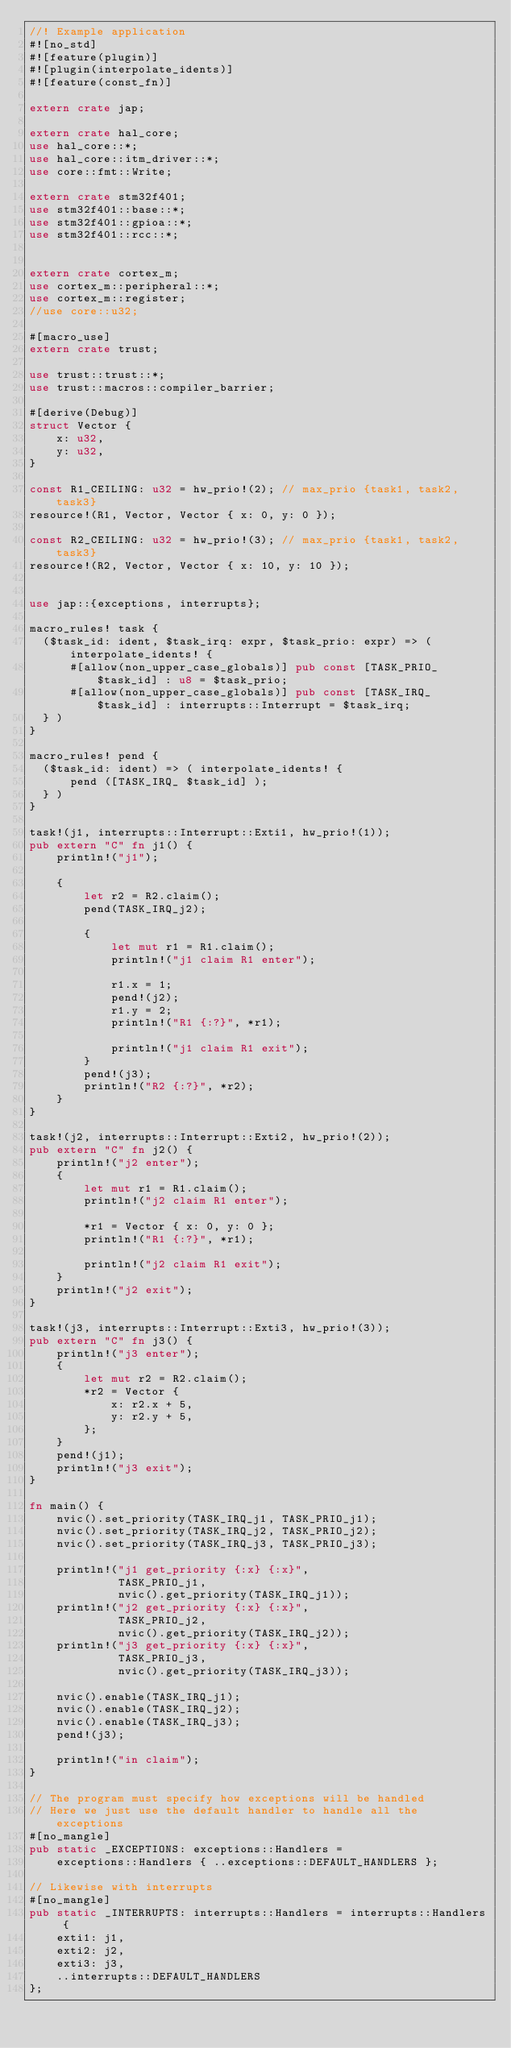Convert code to text. <code><loc_0><loc_0><loc_500><loc_500><_Rust_>//! Example application
#![no_std]
#![feature(plugin)]
#![plugin(interpolate_idents)]
#![feature(const_fn)]

extern crate jap;

extern crate hal_core;
use hal_core::*;
use hal_core::itm_driver::*;
use core::fmt::Write;

extern crate stm32f401;
use stm32f401::base::*;
use stm32f401::gpioa::*;
use stm32f401::rcc::*;


extern crate cortex_m;
use cortex_m::peripheral::*;
use cortex_m::register;
//use core::u32;

#[macro_use]
extern crate trust;

use trust::trust::*;
use trust::macros::compiler_barrier;

#[derive(Debug)]
struct Vector {
    x: u32,
    y: u32,
}

const R1_CEILING: u32 = hw_prio!(2); // max_prio {task1, task2, task3}
resource!(R1, Vector, Vector { x: 0, y: 0 });

const R2_CEILING: u32 = hw_prio!(3); // max_prio {task1, task2, task3}
resource!(R2, Vector, Vector { x: 10, y: 10 });


use jap::{exceptions, interrupts};

macro_rules! task {
  ($task_id: ident, $task_irq: expr, $task_prio: expr) => ( interpolate_idents! {
      #[allow(non_upper_case_globals)] pub const [TASK_PRIO_ $task_id] : u8 = $task_prio;
      #[allow(non_upper_case_globals)] pub const [TASK_IRQ_ $task_id] : interrupts::Interrupt = $task_irq; 
  } )
}

macro_rules! pend {
  ($task_id: ident) => ( interpolate_idents! {
      pend ([TASK_IRQ_ $task_id] ); 
  } )
}

task!(j1, interrupts::Interrupt::Exti1, hw_prio!(1));
pub extern "C" fn j1() {
    println!("j1");

    {
        let r2 = R2.claim();
        pend(TASK_IRQ_j2);

        {
            let mut r1 = R1.claim();
            println!("j1 claim R1 enter");

            r1.x = 1;
            pend!(j2);
            r1.y = 2;
            println!("R1 {:?}", *r1);

            println!("j1 claim R1 exit");
        }
        pend!(j3);
        println!("R2 {:?}", *r2);
    }
}

task!(j2, interrupts::Interrupt::Exti2, hw_prio!(2));
pub extern "C" fn j2() {
    println!("j2 enter");
    {
        let mut r1 = R1.claim();
        println!("j2 claim R1 enter");

        *r1 = Vector { x: 0, y: 0 };
        println!("R1 {:?}", *r1);

        println!("j2 claim R1 exit");
    }
    println!("j2 exit");
}

task!(j3, interrupts::Interrupt::Exti3, hw_prio!(3));
pub extern "C" fn j3() {
    println!("j3 enter");
    {
        let mut r2 = R2.claim();
        *r2 = Vector {
            x: r2.x + 5,
            y: r2.y + 5,
        };
    }
    pend!(j1);
    println!("j3 exit");
}

fn main() {
    nvic().set_priority(TASK_IRQ_j1, TASK_PRIO_j1);
    nvic().set_priority(TASK_IRQ_j2, TASK_PRIO_j2);
    nvic().set_priority(TASK_IRQ_j3, TASK_PRIO_j3);

    println!("j1 get_priority {:x} {:x}",
             TASK_PRIO_j1,
             nvic().get_priority(TASK_IRQ_j1));
    println!("j2 get_priority {:x} {:x}",
             TASK_PRIO_j2,
             nvic().get_priority(TASK_IRQ_j2));
    println!("j3 get_priority {:x} {:x}",
             TASK_PRIO_j3,
             nvic().get_priority(TASK_IRQ_j3));

    nvic().enable(TASK_IRQ_j1);
    nvic().enable(TASK_IRQ_j2);
    nvic().enable(TASK_IRQ_j3);
    pend!(j3);

    println!("in claim");
}

// The program must specify how exceptions will be handled
// Here we just use the default handler to handle all the exceptions
#[no_mangle]
pub static _EXCEPTIONS: exceptions::Handlers =
    exceptions::Handlers { ..exceptions::DEFAULT_HANDLERS };

// Likewise with interrupts
#[no_mangle]
pub static _INTERRUPTS: interrupts::Handlers = interrupts::Handlers {
    exti1: j1,
    exti2: j2,
    exti3: j3,
    ..interrupts::DEFAULT_HANDLERS
};
</code> 